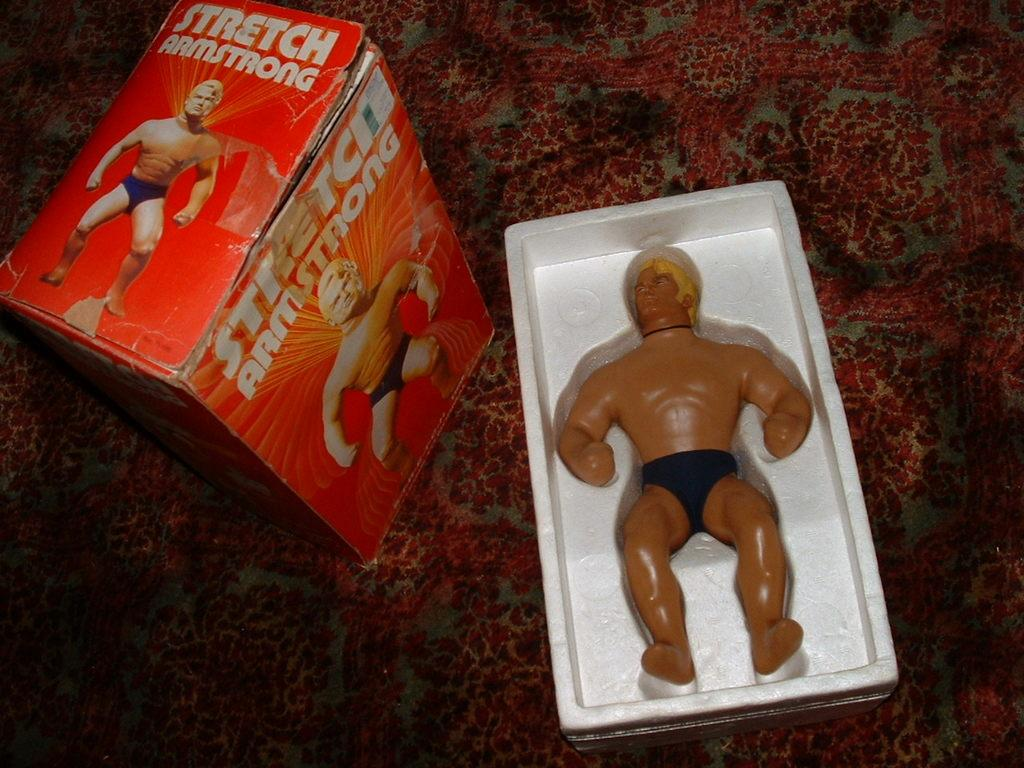What object is present in the image that is typically used for play? There is a toy in the image. Where is the toy stored in the image? The toy is kept in a box. What type of container is used to store the toy in the image? There is a toy box in the image. On what piece of furniture is the toy box placed in the image? The toy box is kept on a table. What type of steel is used to construct the toy in the image? There is no mention of steel or any specific material used to construct the toy in the image. 